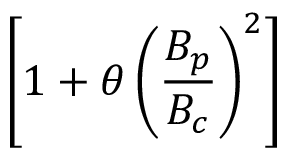<formula> <loc_0><loc_0><loc_500><loc_500>\left [ 1 + \theta \left ( \frac { B _ { p } } { B _ { c } } \right ) ^ { 2 } \right ]</formula> 